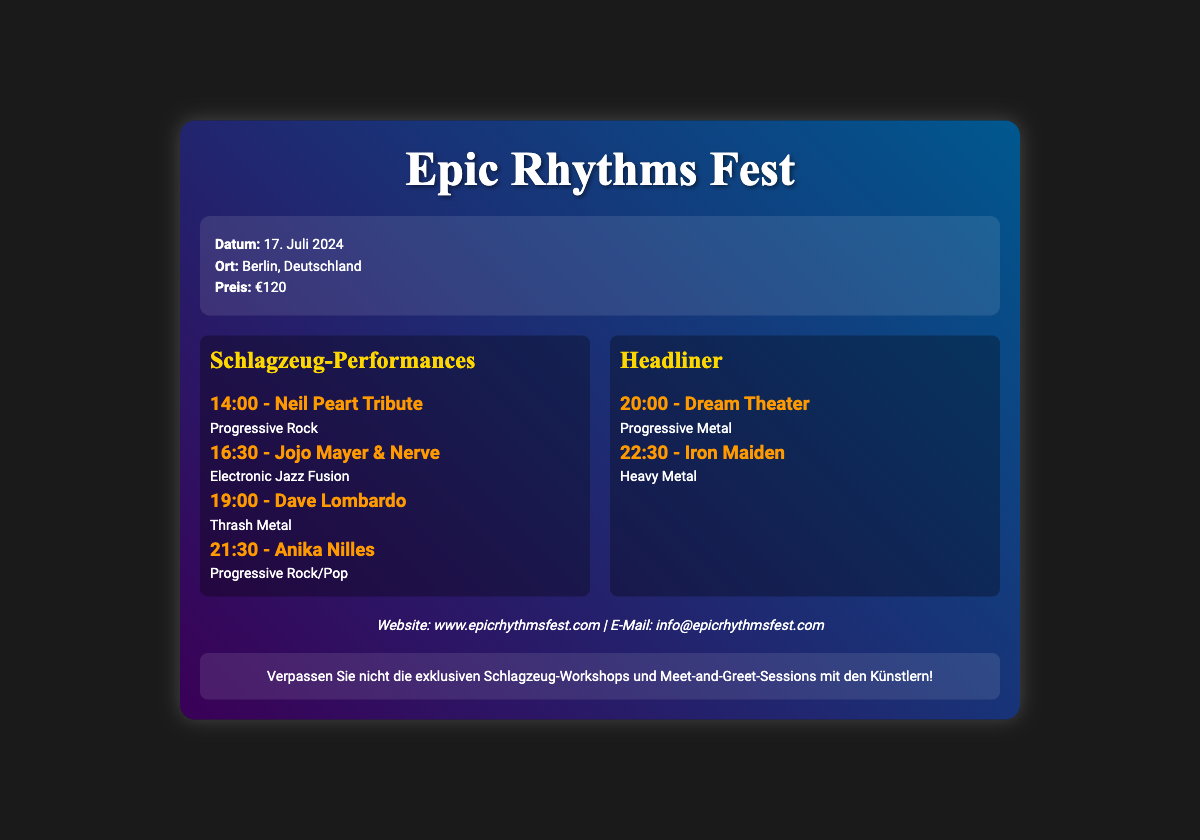What is the event date? The event date is specified in the document as the day the festival occurs.
Answer: 17. Juli 2024 Where is the festival taking place? The document states the location of the music festival in Berlin.
Answer: Berlin, Deutschland What is the price of the ticket? The price information is clearly mentioned in the ticket details of the document.
Answer: €120 Who is performing at 19:00? The document provides the schedule of performances along with the names of the artists and their performance times.
Answer: Dave Lombardo Which band is the headliner at 22:30? The schedule lists the headliner's name and time, indicating the closing act of the event.
Answer: Iron Maiden What genre does Jojo Mayer & Nerve represent? The genre associated with Jojo Mayer & Nerve is included with their performance schedule.
Answer: Electronic Jazz Fusion How many drum performances are listed? By counting the individual performances, the total number can be determined from the document's performance section.
Answer: 4 What additional events are mentioned in the notes? The notes section includes details about exclusive events that accompany the main performances.
Answer: Schlagzeug-Workshops and Meet-and-Greet-Sessions Who are the two headliners listed in the ticket? The document provides details about the two main acts concluding the festival.
Answer: Dream Theater and Iron Maiden 